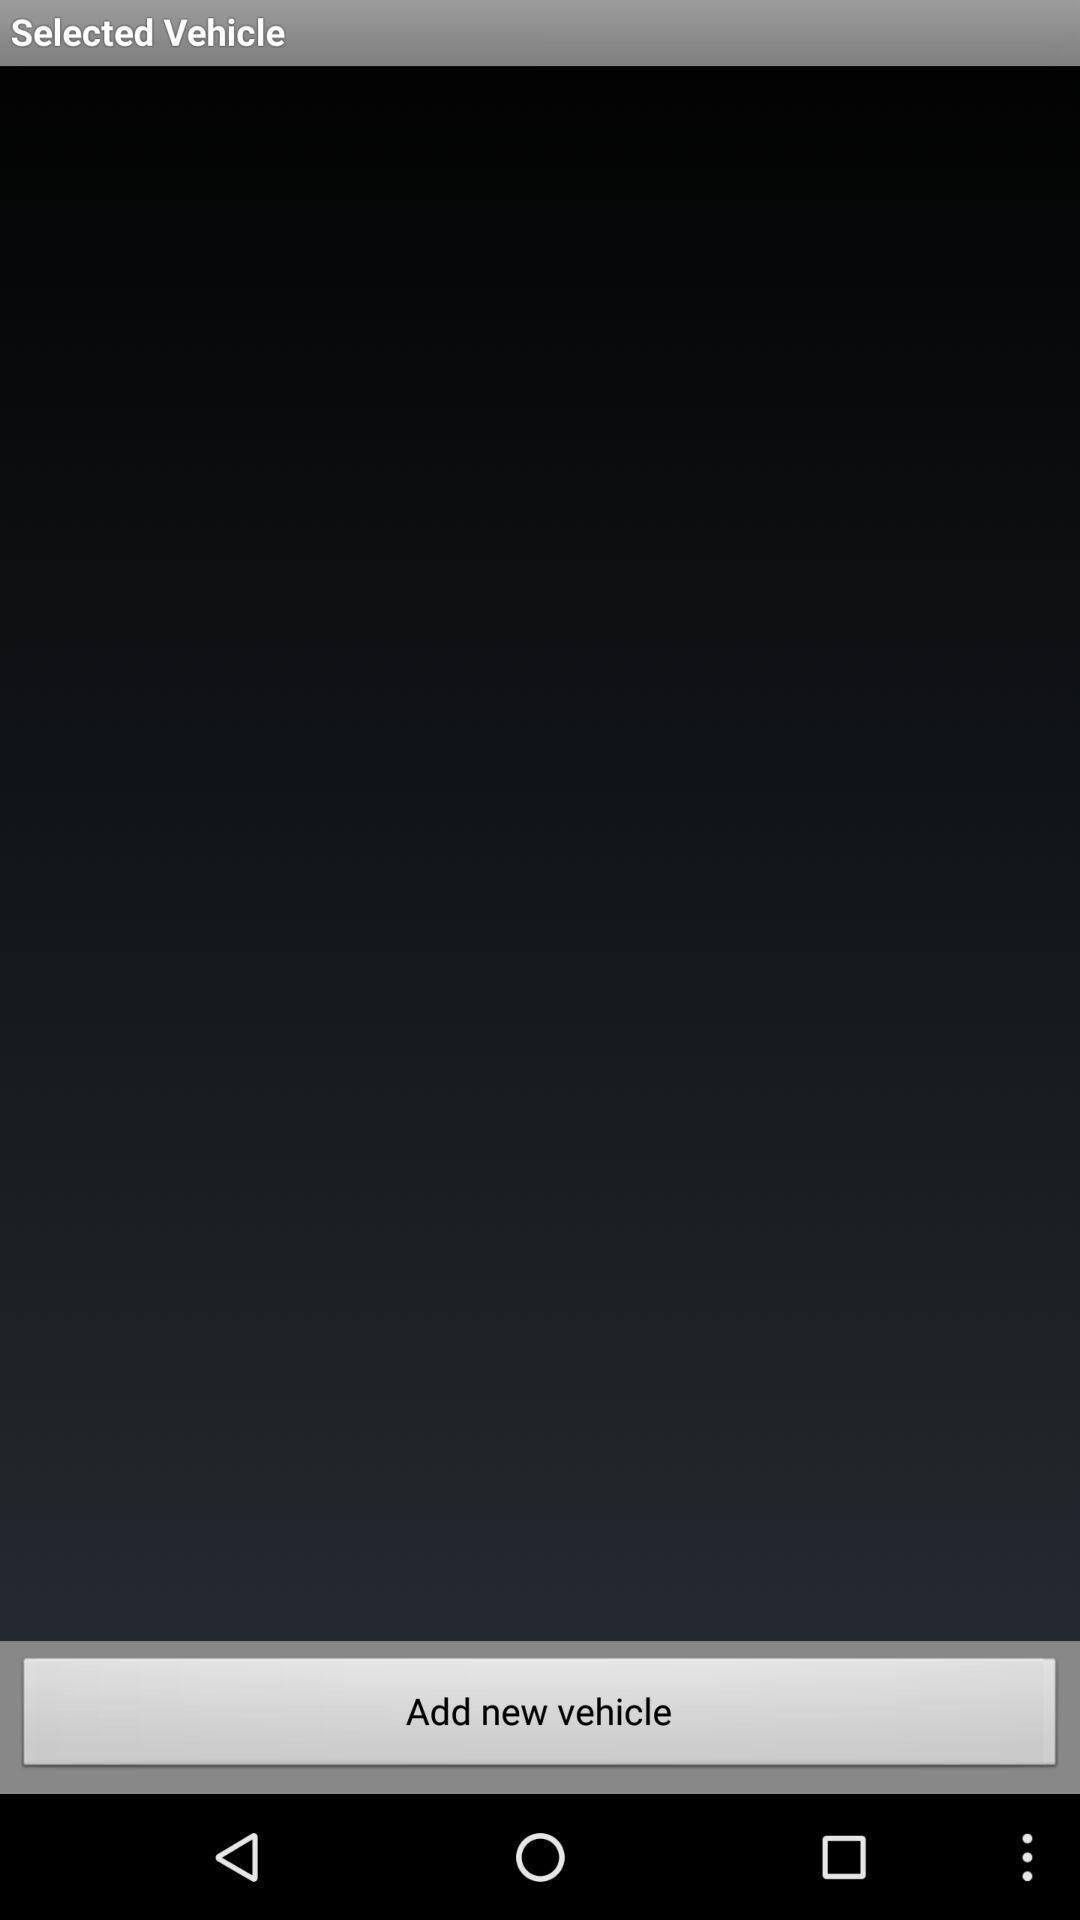Describe the content in this image. Page showing add new vehicle. 